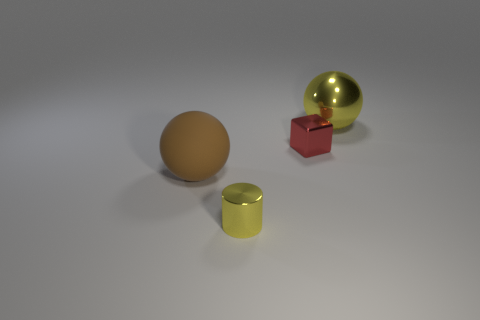Add 2 cubes. How many objects exist? 6 Subtract 1 cylinders. How many cylinders are left? 0 Subtract all cylinders. How many objects are left? 3 Subtract all tiny red shiny things. Subtract all big red rubber cubes. How many objects are left? 3 Add 2 large yellow metallic objects. How many large yellow metallic objects are left? 3 Add 3 big rubber objects. How many big rubber objects exist? 4 Subtract 0 cyan balls. How many objects are left? 4 Subtract all purple cylinders. Subtract all blue balls. How many cylinders are left? 1 